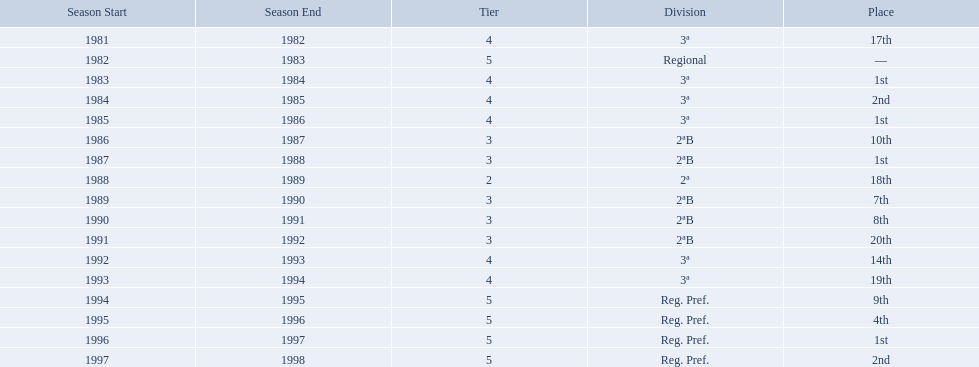Which years did the team have a season? 1981/82, 1982/83, 1983/84, 1984/85, 1985/86, 1986/87, 1987/88, 1988/89, 1989/90, 1990/91, 1991/92, 1992/93, 1993/94, 1994/95, 1995/96, 1996/97, 1997/98. Which of those years did the team place outside the top 10? 1981/82, 1988/89, 1991/92, 1992/93, 1993/94. Would you be able to parse every entry in this table? {'header': ['Season Start', 'Season End', 'Tier', 'Division', 'Place'], 'rows': [['1981', '1982', '4', '3ª', '17th'], ['1982', '1983', '5', 'Regional', '—'], ['1983', '1984', '4', '3ª', '1st'], ['1984', '1985', '4', '3ª', '2nd'], ['1985', '1986', '4', '3ª', '1st'], ['1986', '1987', '3', '2ªB', '10th'], ['1987', '1988', '3', '2ªB', '1st'], ['1988', '1989', '2', '2ª', '18th'], ['1989', '1990', '3', '2ªB', '7th'], ['1990', '1991', '3', '2ªB', '8th'], ['1991', '1992', '3', '2ªB', '20th'], ['1992', '1993', '4', '3ª', '14th'], ['1993', '1994', '4', '3ª', '19th'], ['1994', '1995', '5', 'Reg. Pref.', '9th'], ['1995', '1996', '5', 'Reg. Pref.', '4th'], ['1996', '1997', '5', 'Reg. Pref.', '1st'], ['1997', '1998', '5', 'Reg. Pref.', '2nd']]} Which of the years in which the team placed outside the top 10 did they have their worst performance? 1991/92. 